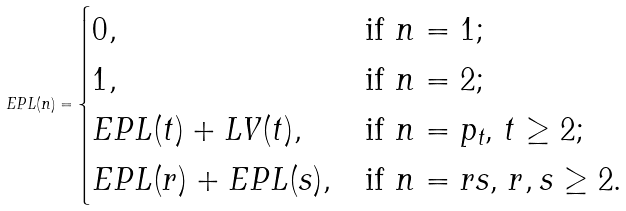<formula> <loc_0><loc_0><loc_500><loc_500>E P L ( n ) = \begin{cases} 0 , & \text {if $n=1$;} \\ 1 , & \text {if $n=2$;} \\ E P L ( t ) + L V ( t ) , & \text {if $n=p_{t}$, $t\geq 2$;} \\ E P L ( r ) + E P L ( s ) , & \text {if $n=rs$, $r,s \geq 2$.} \end{cases}</formula> 